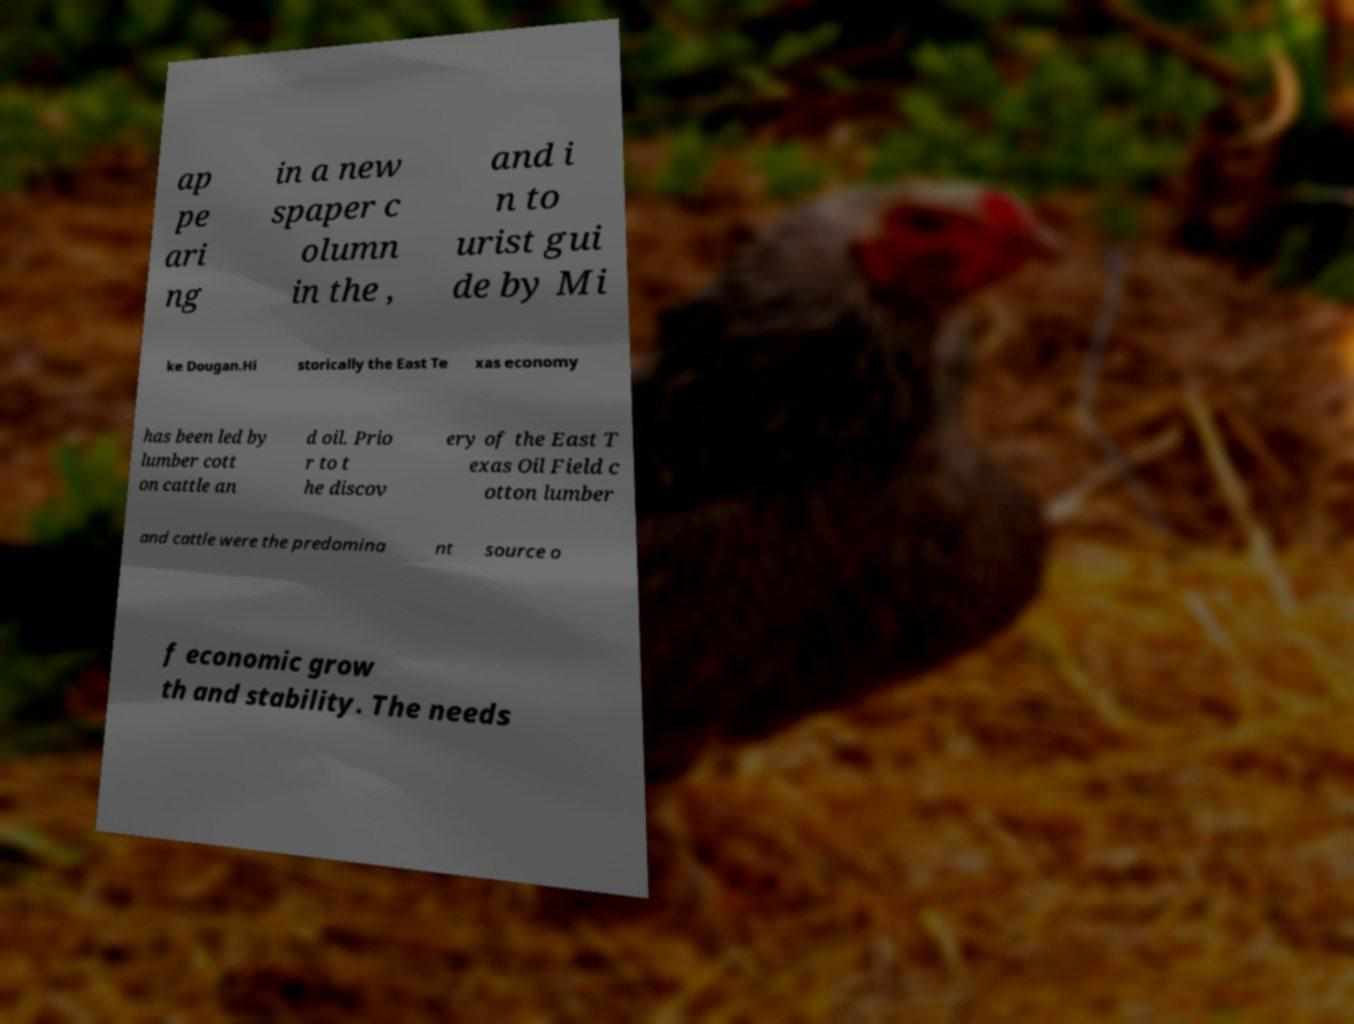Could you extract and type out the text from this image? ap pe ari ng in a new spaper c olumn in the , and i n to urist gui de by Mi ke Dougan.Hi storically the East Te xas economy has been led by lumber cott on cattle an d oil. Prio r to t he discov ery of the East T exas Oil Field c otton lumber and cattle were the predomina nt source o f economic grow th and stability. The needs 